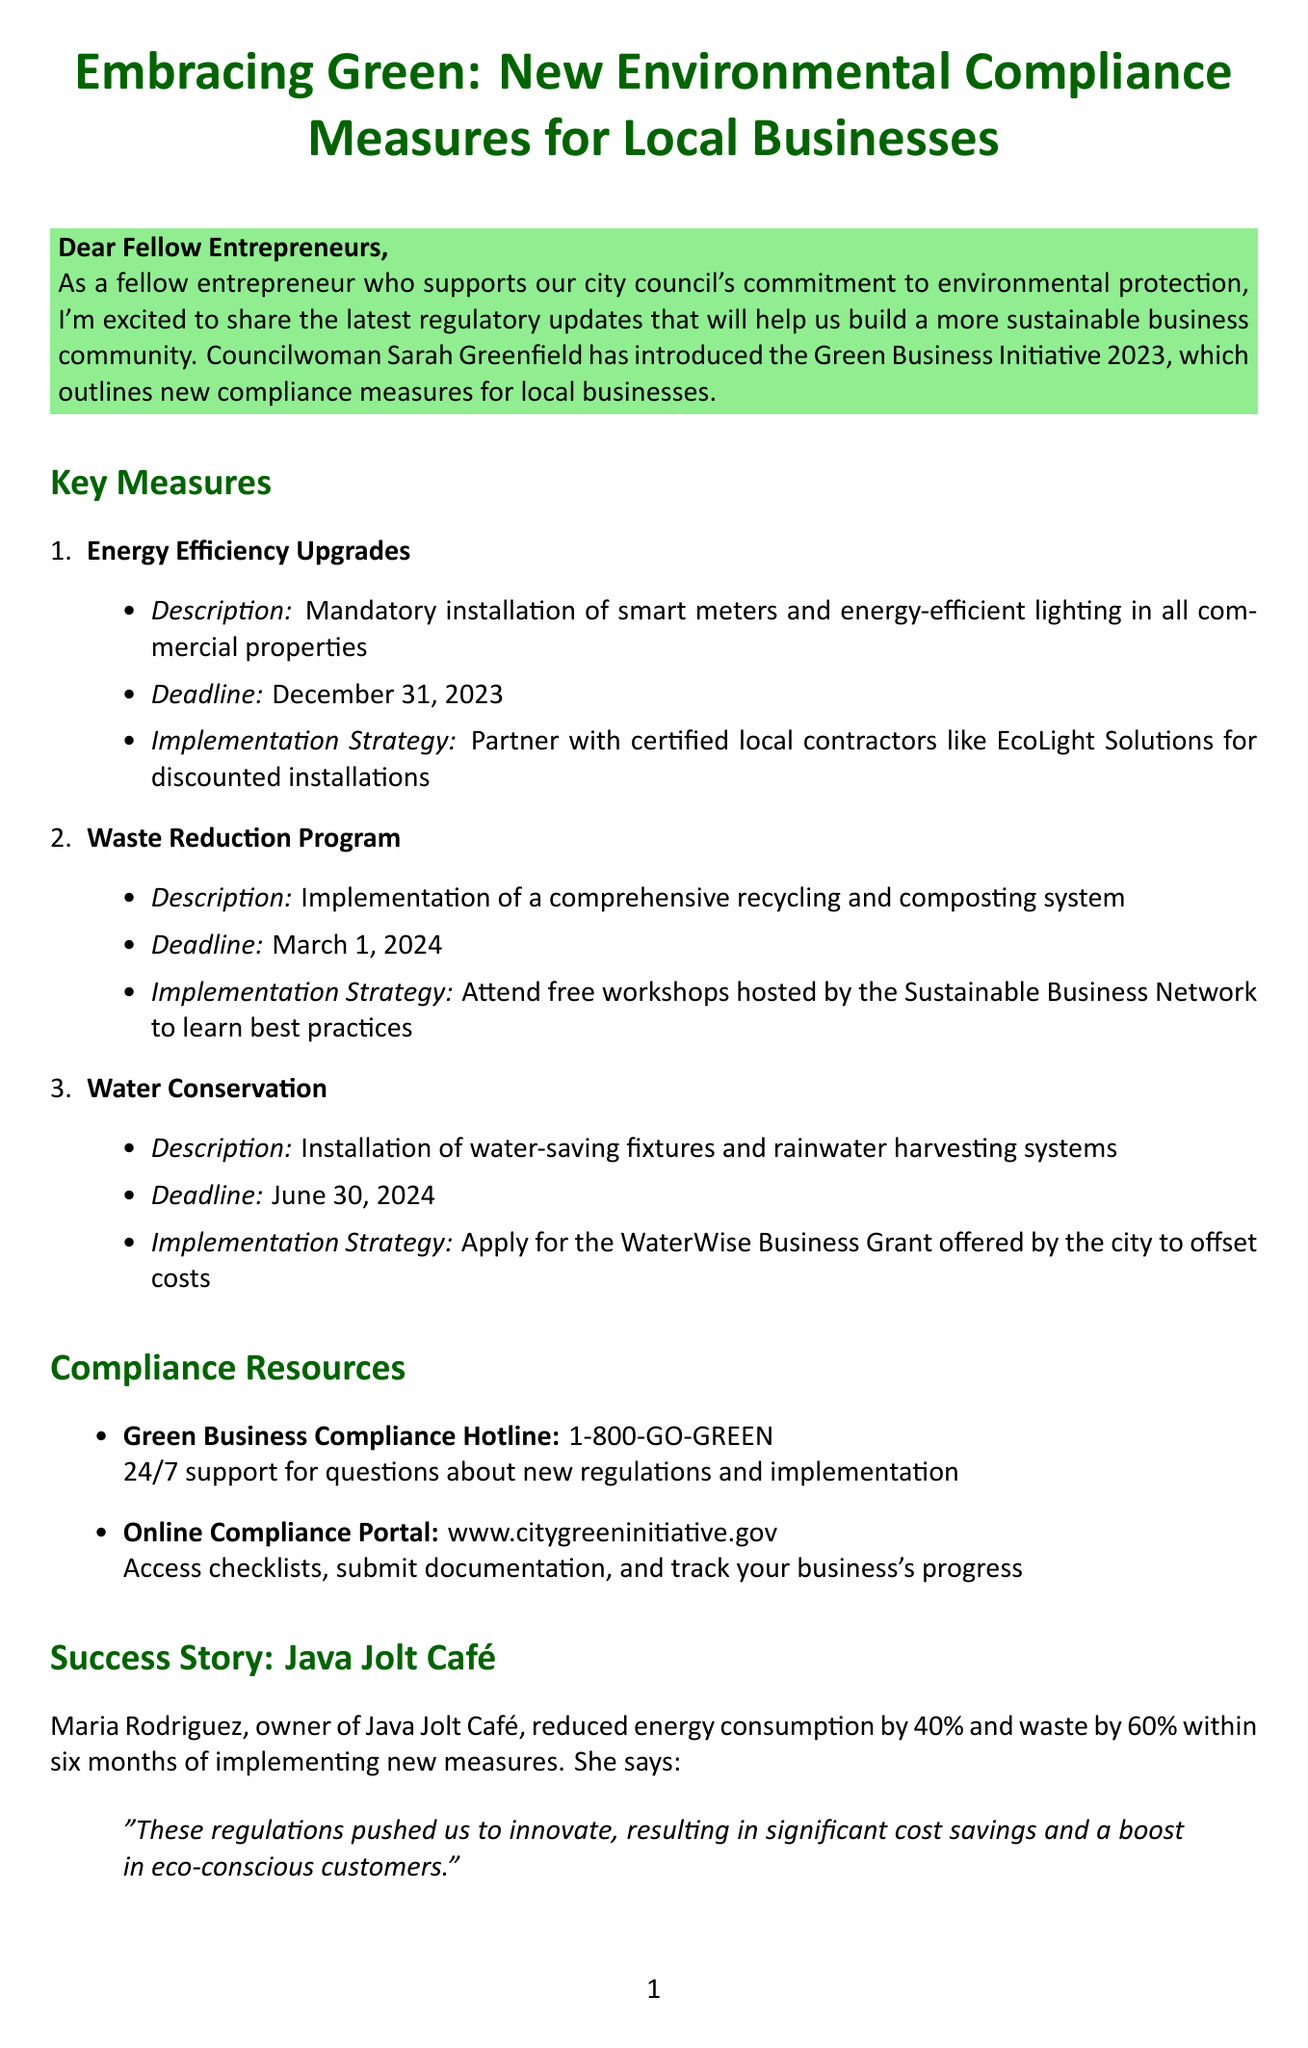what is the name of the initiative? The regulation introduced by the councilwoman is titled the "Green Business Initiative 2023."
Answer: Green Business Initiative 2023 what is the deadline for Energy Efficiency Upgrades? The document states that the deadline for the installation of smart meters and energy-efficient lighting is December 31, 2023.
Answer: December 31, 2023 which business reduced energy consumption by 40%? The success story highlights that Java Jolt Café achieved a 40% reduction in energy consumption.
Answer: Java Jolt Café what is the contact number for the compliance hotline? The newsletter provides a contact number for the Green Business Compliance Hotline, which is 1-800-GO-GREEN.
Answer: 1-800-GO-GREEN how many days are the compliance workshops scheduled for? The Compliance Workshop Series includes three specific dates: October 5, 12, and 19, 2023.
Answer: Three days what is the implementation strategy for the Water Conservation measure? The implementation strategy suggests applying for the WaterWise Business Grant to help with the installation costs.
Answer: Apply for the WaterWise Business Grant when is the Green Business Expo taking place? According to the document, the Green Business Expo is scheduled for September 15, 2023.
Answer: September 15, 2023 who is the owner of Java Jolt Café? The owner of Java Jolt Café, who is mentioned in the success story, is Maria Rodriguez.
Answer: Maria Rodriguez what type of support does the compliance hotline offer? The newsletter specifies that the Green Business Compliance Hotline offers 24/7 support for questions about regulations.
Answer: 24/7 support 